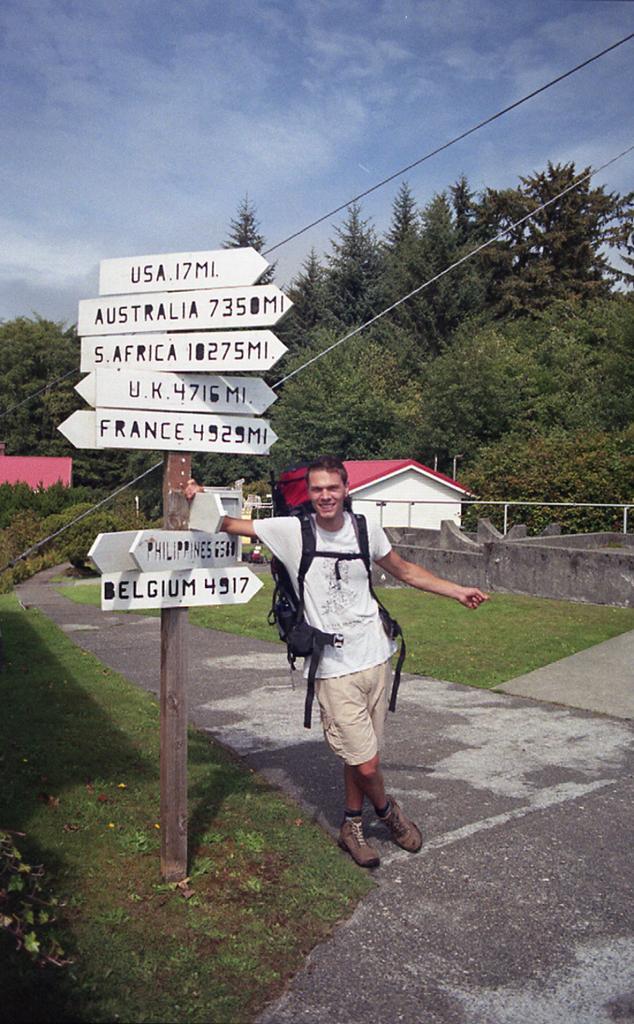Please provide a concise description of this image. In this image there is a person standing beside the directional board. On both right and left side of the image there is grass on the surface. In the center of the image there is a road. In the background of the image there are buildings, trees and sky. 